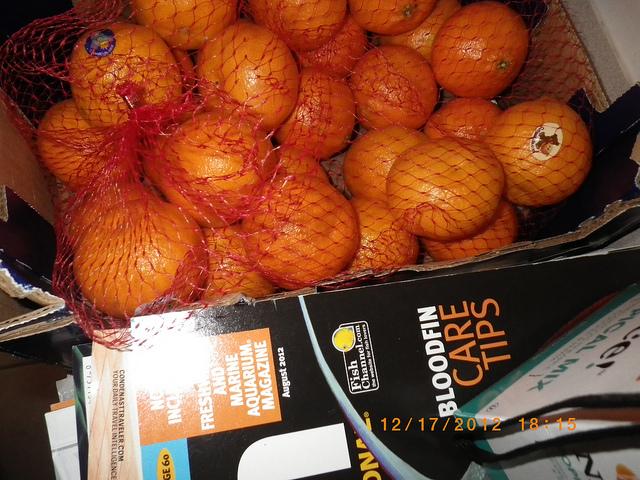How many oranges are in the bag?
Concise answer only. 24. What is the date stamp on this photo?
Be succinct. 12/17/2012. In what city was this fruit picked?
Write a very short answer. Orlando. What kind of fruit is in the netting?
Give a very brief answer. Oranges. 